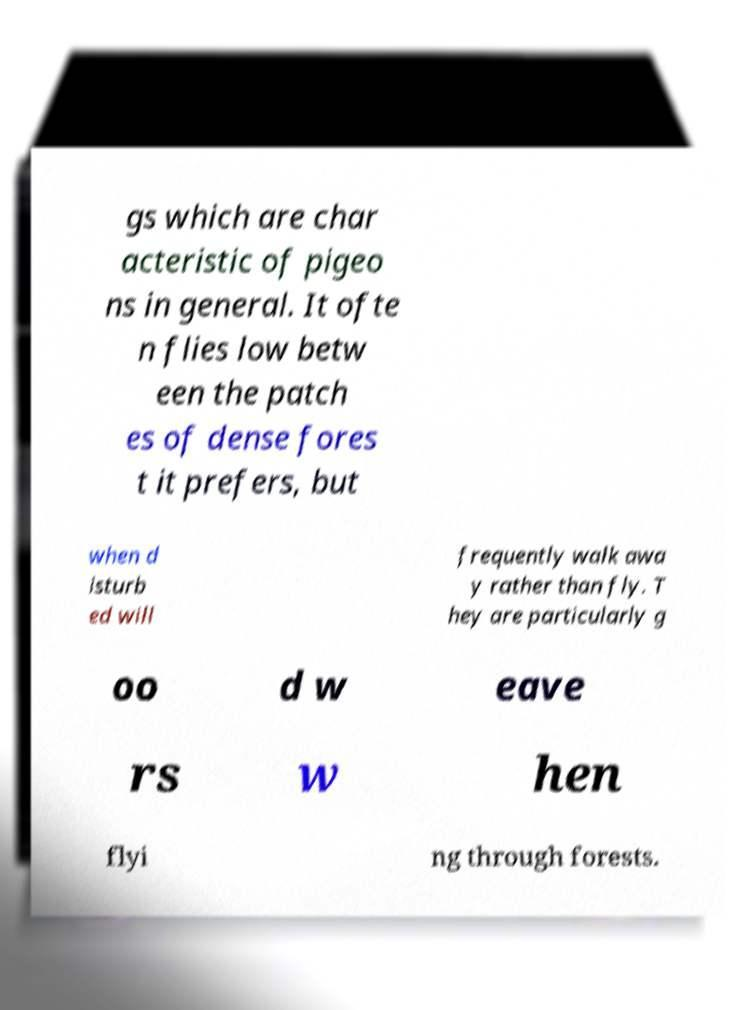What messages or text are displayed in this image? I need them in a readable, typed format. gs which are char acteristic of pigeo ns in general. It ofte n flies low betw een the patch es of dense fores t it prefers, but when d isturb ed will frequently walk awa y rather than fly. T hey are particularly g oo d w eave rs w hen flyi ng through forests. 